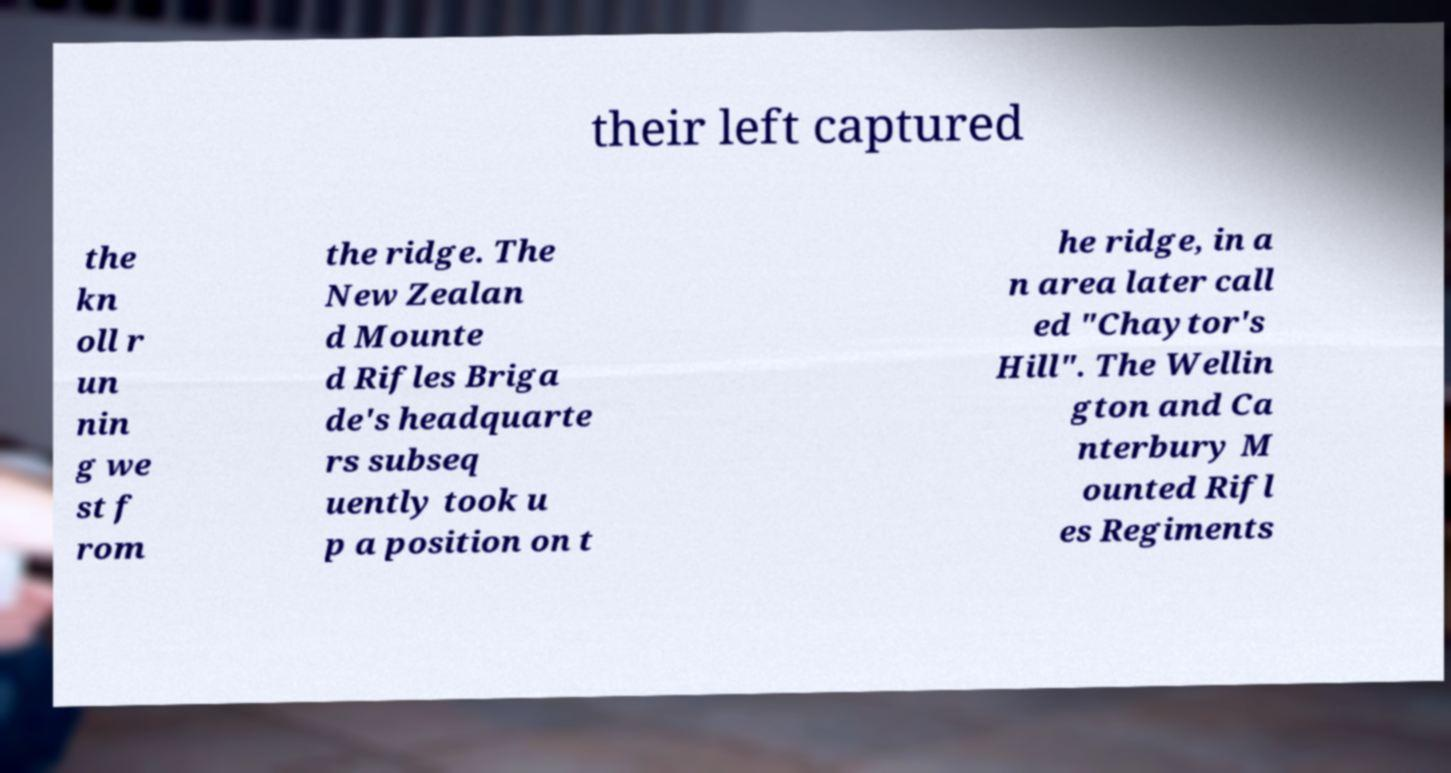What messages or text are displayed in this image? I need them in a readable, typed format. their left captured the kn oll r un nin g we st f rom the ridge. The New Zealan d Mounte d Rifles Briga de's headquarte rs subseq uently took u p a position on t he ridge, in a n area later call ed "Chaytor's Hill". The Wellin gton and Ca nterbury M ounted Rifl es Regiments 